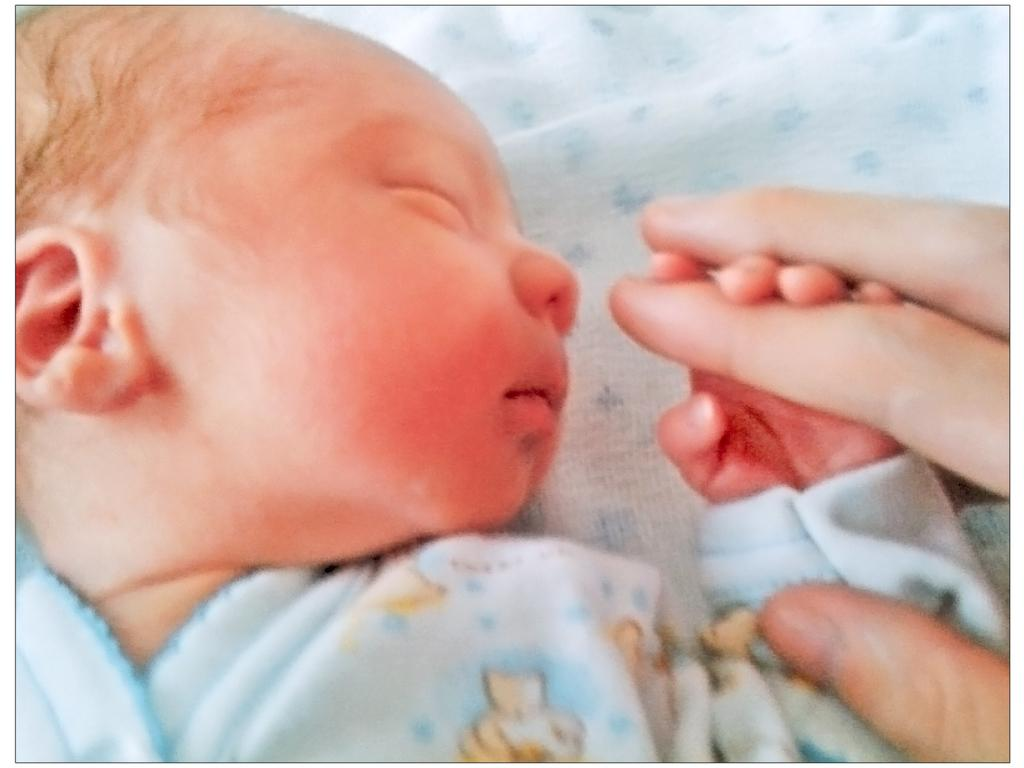What is the main subject of the image? The main subject of the image is a baby. What is the baby doing in the image? The baby is holding a finger of a person. How many toes can be seen on the baby in the image? The image does not show the baby's toes, so it cannot be determined from the picture. 